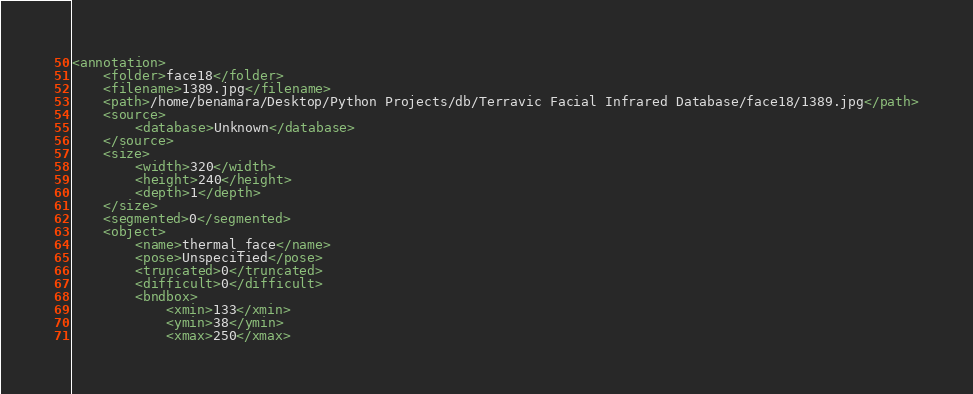Convert code to text. <code><loc_0><loc_0><loc_500><loc_500><_XML_><annotation>
	<folder>face18</folder>
	<filename>1389.jpg</filename>
	<path>/home/benamara/Desktop/Python Projects/db/Terravic Facial Infrared Database/face18/1389.jpg</path>
	<source>
		<database>Unknown</database>
	</source>
	<size>
		<width>320</width>
		<height>240</height>
		<depth>1</depth>
	</size>
	<segmented>0</segmented>
	<object>
		<name>thermal_face</name>
		<pose>Unspecified</pose>
		<truncated>0</truncated>
		<difficult>0</difficult>
		<bndbox>
			<xmin>133</xmin>
			<ymin>38</ymin>
			<xmax>250</xmax></code> 